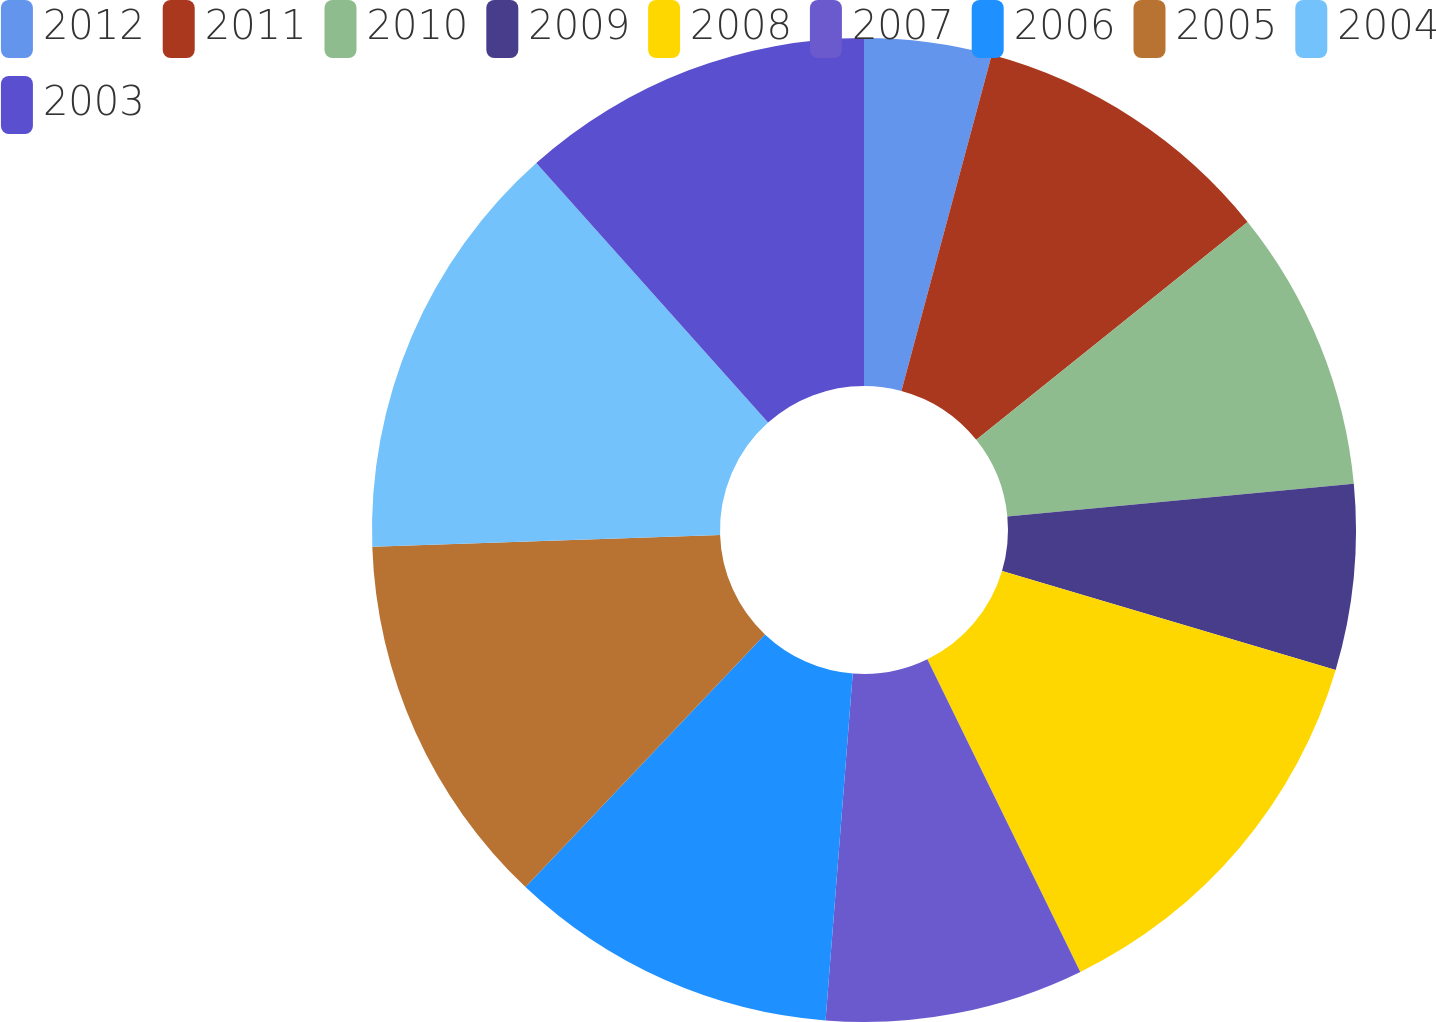<chart> <loc_0><loc_0><loc_500><loc_500><pie_chart><fcel>2012<fcel>2011<fcel>2010<fcel>2009<fcel>2008<fcel>2007<fcel>2006<fcel>2005<fcel>2004<fcel>2003<nl><fcel>4.18%<fcel>10.05%<fcel>9.27%<fcel>6.09%<fcel>13.16%<fcel>8.49%<fcel>10.83%<fcel>12.38%<fcel>13.94%<fcel>11.6%<nl></chart> 